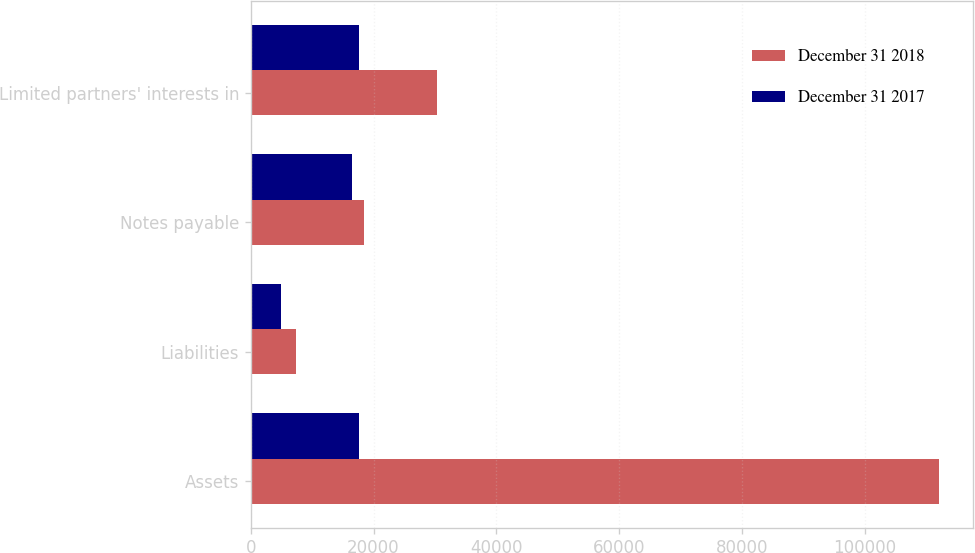Convert chart. <chart><loc_0><loc_0><loc_500><loc_500><stacked_bar_chart><ecel><fcel>Assets<fcel>Liabilities<fcel>Notes payable<fcel>Limited partners' interests in<nl><fcel>December 31 2018<fcel>112085<fcel>7309<fcel>18432<fcel>30280<nl><fcel>December 31 2017<fcel>17572<fcel>4993<fcel>16551<fcel>17572<nl></chart> 